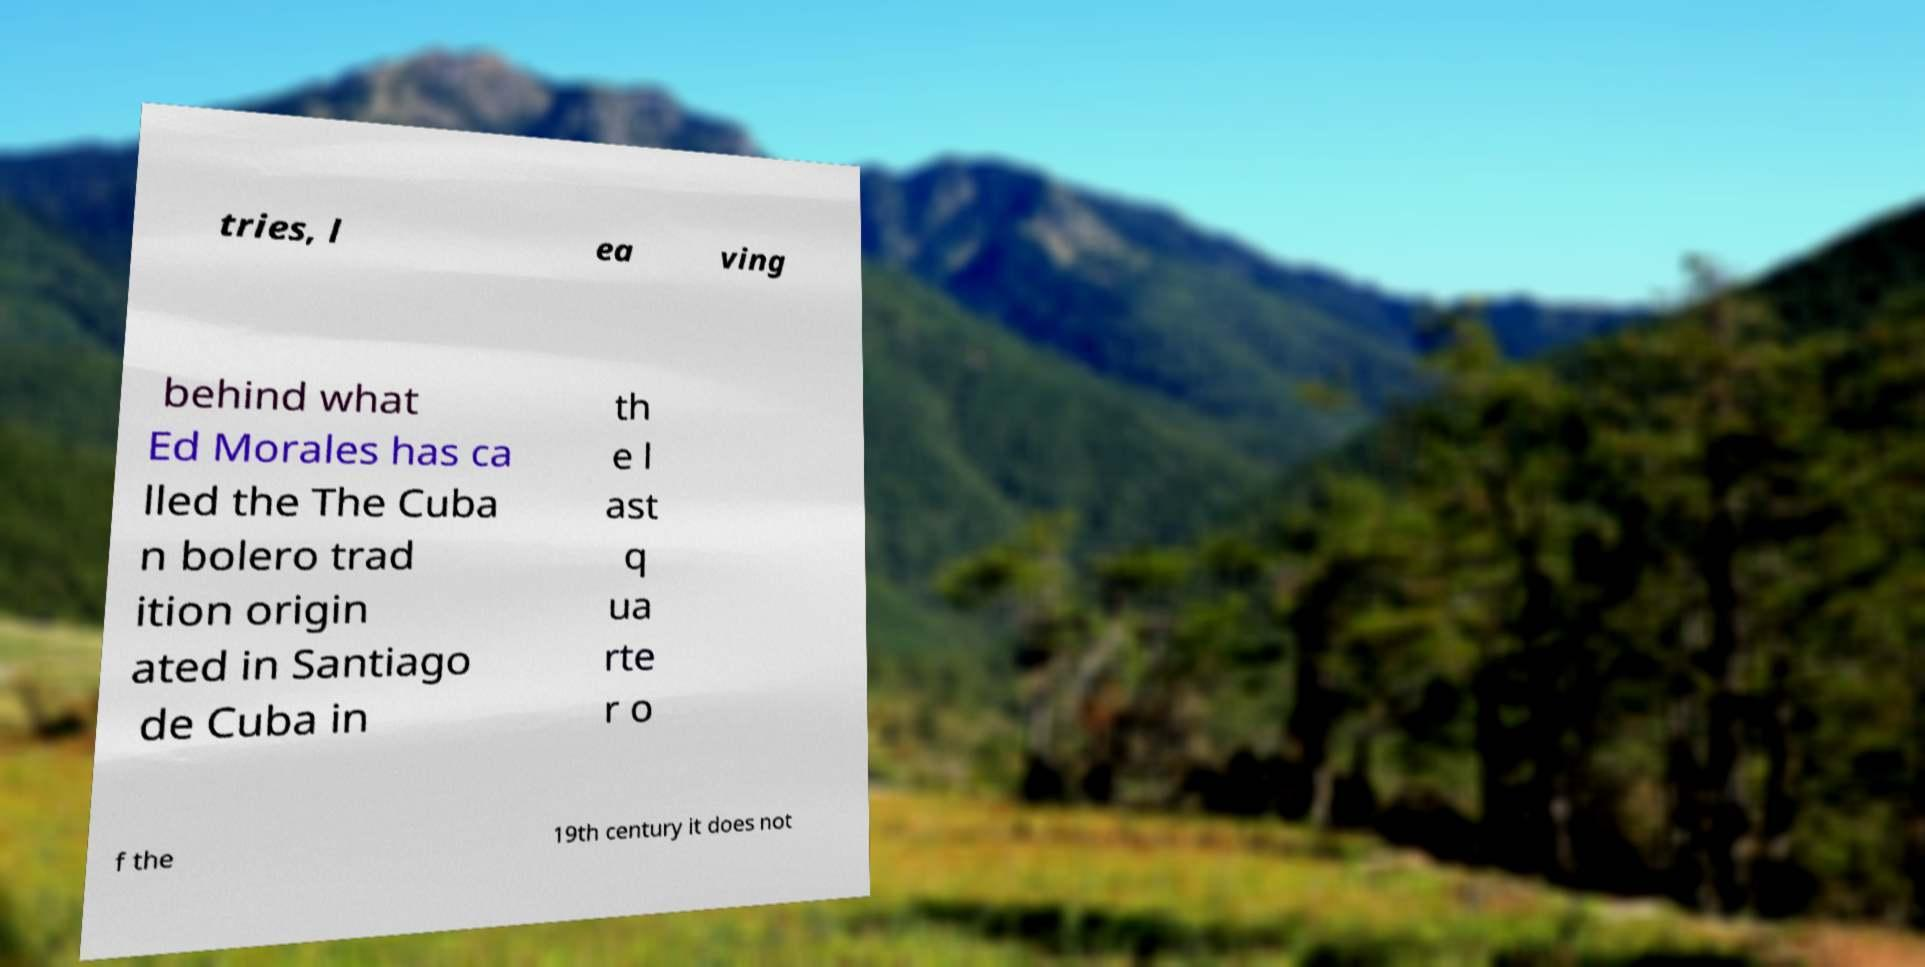For documentation purposes, I need the text within this image transcribed. Could you provide that? tries, l ea ving behind what Ed Morales has ca lled the The Cuba n bolero trad ition origin ated in Santiago de Cuba in th e l ast q ua rte r o f the 19th century it does not 